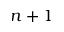<formula> <loc_0><loc_0><loc_500><loc_500>n + 1</formula> 